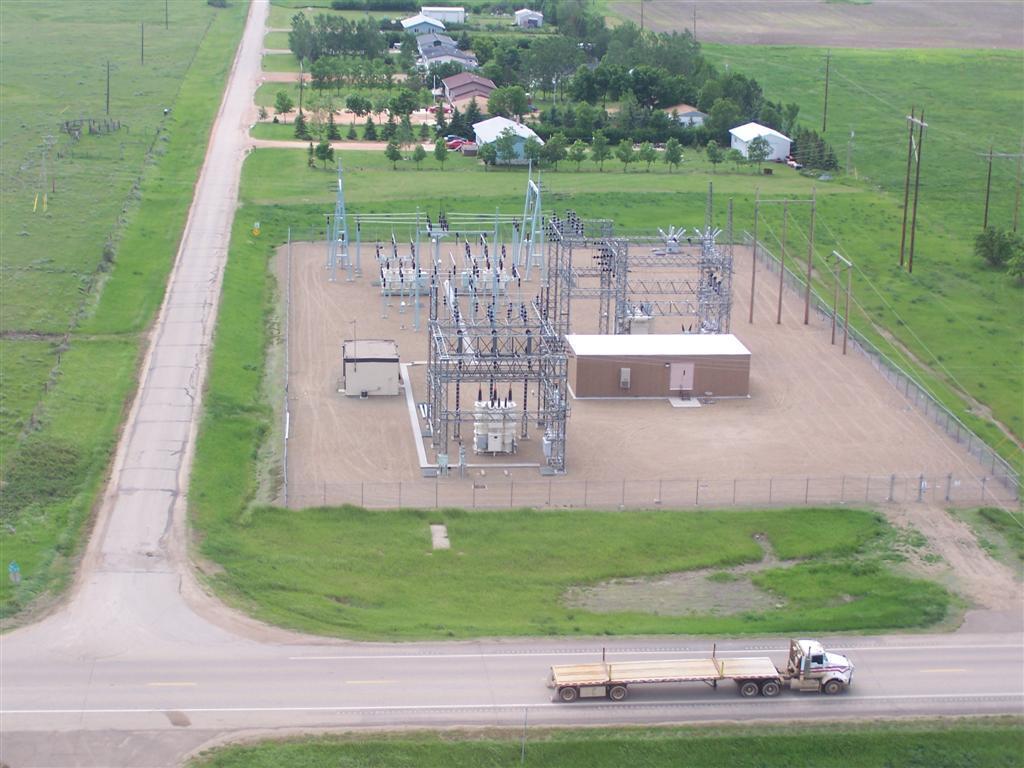How would you summarize this image in a sentence or two? At the bottom there is a vehicle on the road and we can see grass on the ground. In the background there are poles,houses,electric wires,road,trees,path,electricity station and other objects. 